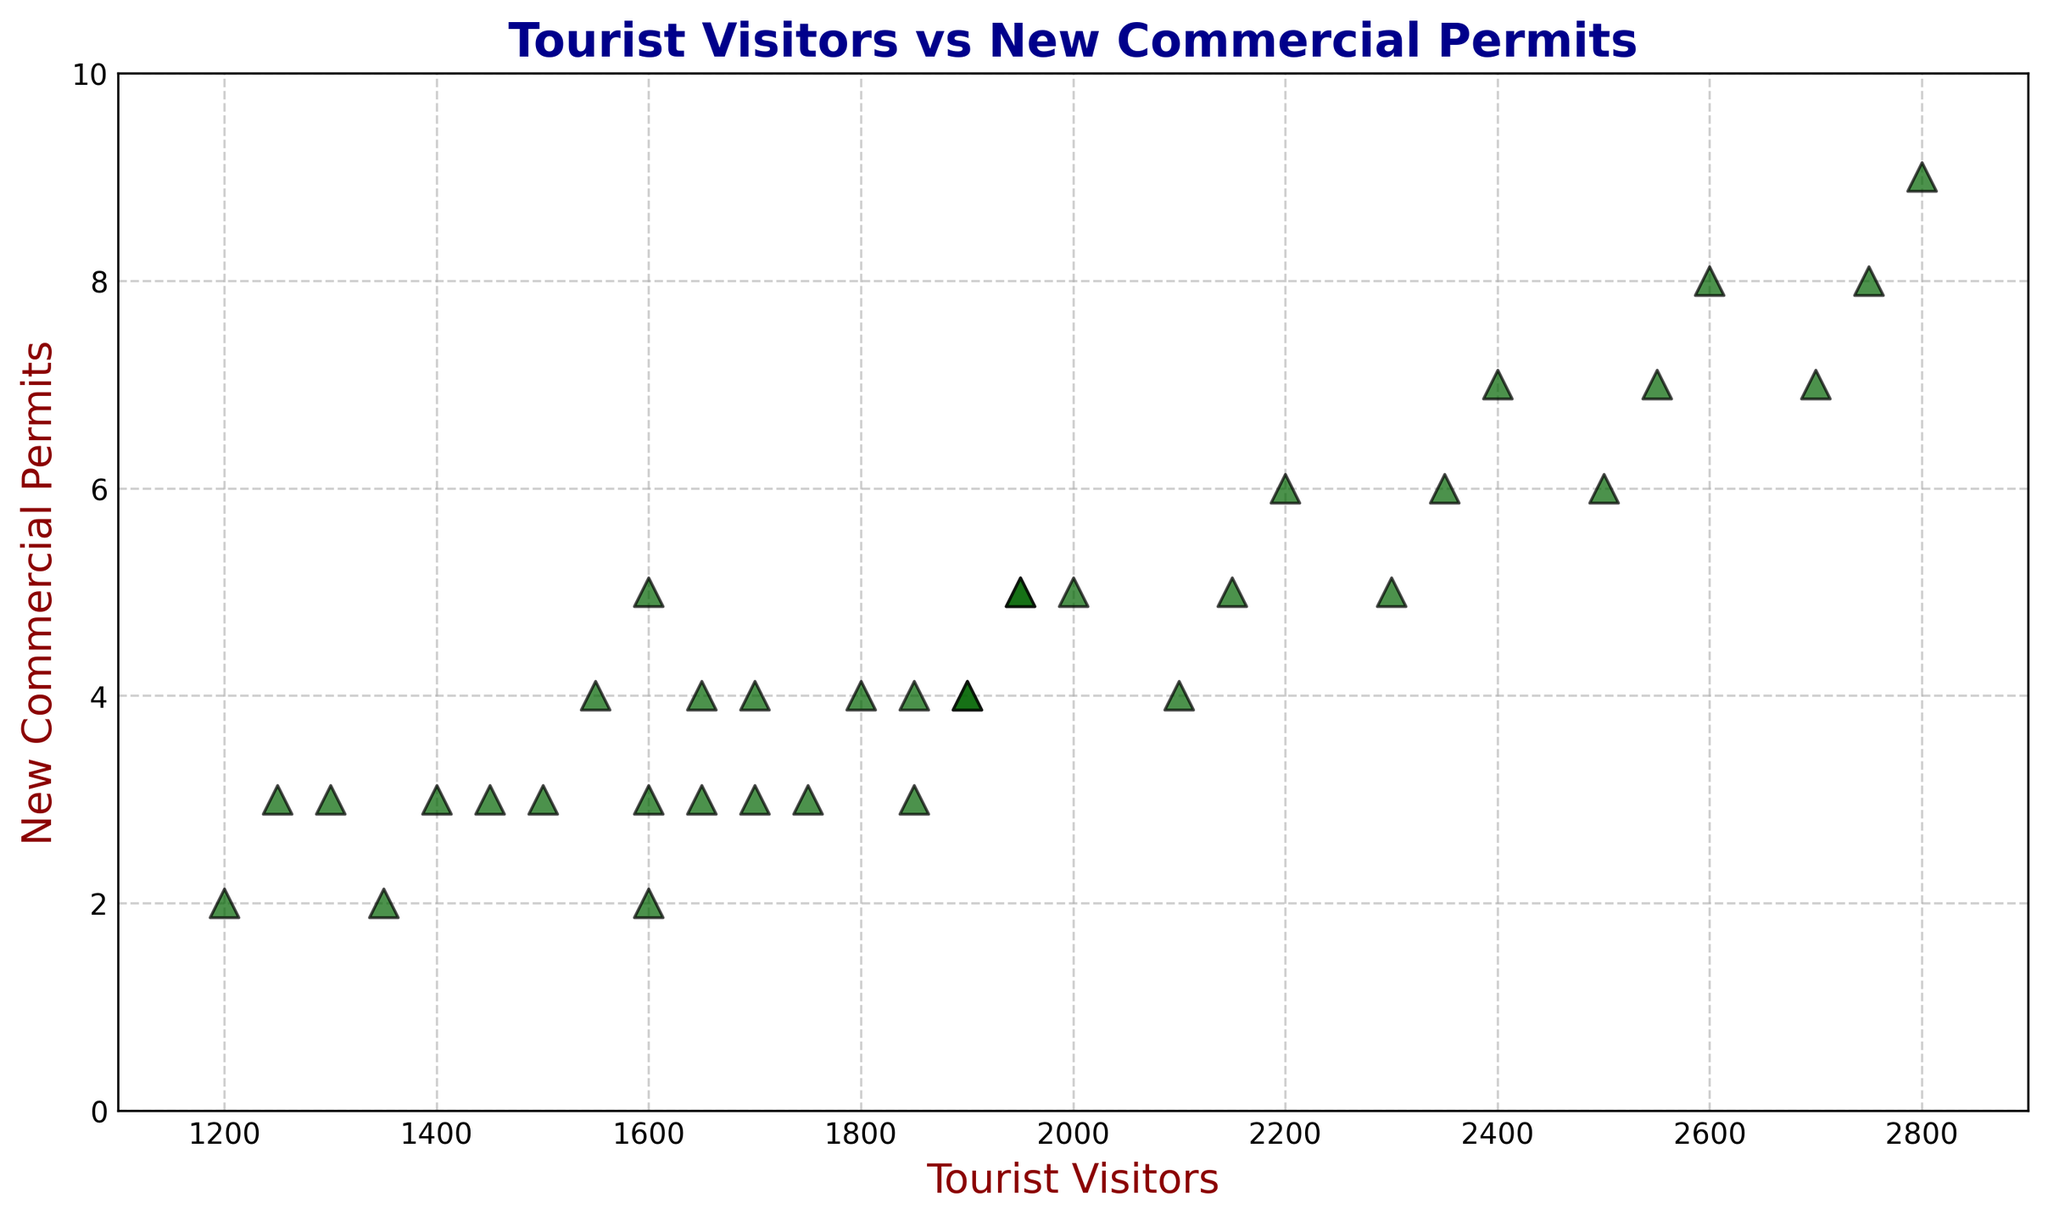What is the total number of new commercial permits issued when tourist visitors are at or above 2700? From the scatter plot, identify all points where tourist visitors are at or above 2700: these are 2700, 2750, and 2800. The corresponding permits for these tourist visitor numbers are 7, 8, and 9. Summing these values: 7 + 8 + 9 = 24.
Answer: 24 Which month(s) and year(s) had the highest number of tourist visitors, and what was the corresponding number of new commercial permits? The highest number of tourist visitors on the scatter plot is 2800, corresponding to August 2023. The corresponding number of new commercial permits for 2800 tourist visitors is 9.
Answer: August 2023, 9 permits Is there a general trend between tourist visitors and new commercial permits? If so, what is it? From the scatter plot, observe that as the number of tourist visitors increases, the number of new commercial permits generally increases as well. This indicates a positive correlation between the two variables.
Answer: Positive correlation Compare July 2021 and July 2023 data. How many more new commercial permits were issued in July 2023 compared to July 2021? Identify the data points for July 2021 and July 2023 on the scatter plot. For July 2021, the tourist visitors are 2500 with 6 permits. For July 2023, the tourist visitors are 2600 with 8 permits. The difference in permits is 8 - 6 = 2.
Answer: 2 What is the range of tourist visitors and new commercial permits displayed in the scatter plot? Determine the smallest and largest values for both tourist visitors and new commercial permits from the scatter plot. The range of tourist visitors is from 1200 to 2800 (2800 - 1200 = 1600). The range of new commercial permits is from 2 to 9 (9 - 2 = 7).
Answer: Tourist Visitors: 1600, New Commercial Permits: 7 Which data point corresponds to the lowest number of new commercial permits? What are its tourist visitor numbers and the specific month/year? Identify the data point with the lowest number of new commercial permits from the scatter plot. The lowest permits number is 2, with tourist visitors at 1200 (January 2021), 1350 (February 2021), and 1600 (November 2021).
Answer: 1200 (January 2021), 1350 (February 2021), 1600 (November 2021) Determine the average number of tourist visitors for all months where new commercial permits equal to 4. Identify all points where the new commercial permits are 4: 2100 (May 2021), 1900 (April 2022), 2150 (May 2022), 1800 (October 2022), 1700 (March 2023), and 1850 (October 2023). The average is calculated as (2100 + 1900 + 2150 + 1800 + 1700 + 1850) / 6. Sum = 11500, so average = 11500 / 6 ≈ 1916.67.
Answer: 1916.67 